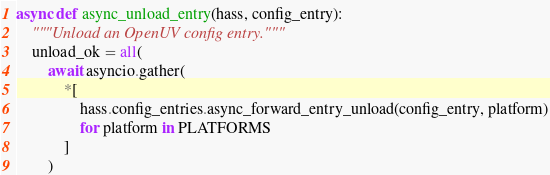Convert code to text. <code><loc_0><loc_0><loc_500><loc_500><_Python_>async def async_unload_entry(hass, config_entry):
    """Unload an OpenUV config entry."""
    unload_ok = all(
        await asyncio.gather(
            *[
                hass.config_entries.async_forward_entry_unload(config_entry, platform)
                for platform in PLATFORMS
            ]
        )</code> 